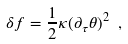Convert formula to latex. <formula><loc_0><loc_0><loc_500><loc_500>\delta f = \frac { 1 } { 2 } \kappa ( \partial _ { \tau } \theta ) ^ { 2 } \ ,</formula> 